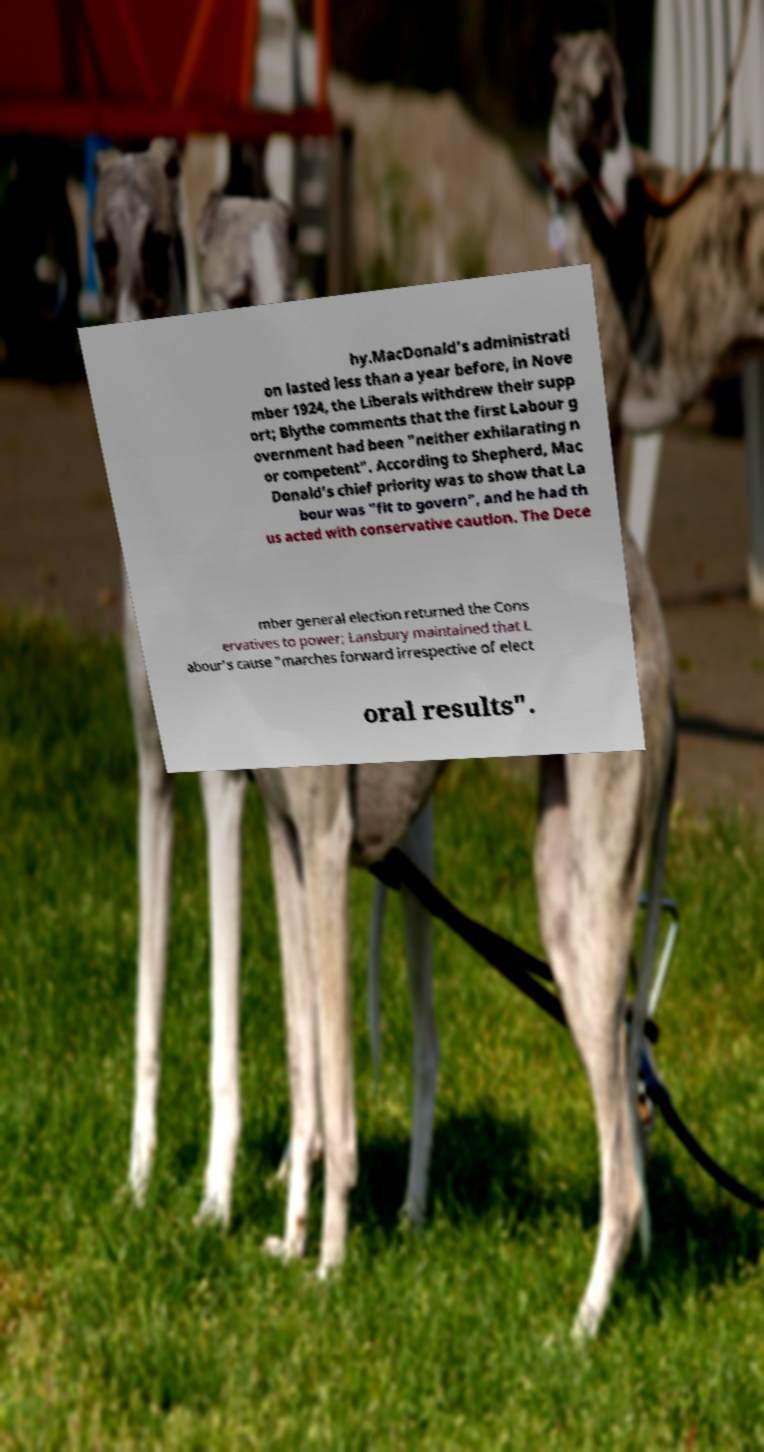Could you extract and type out the text from this image? hy.MacDonald's administrati on lasted less than a year before, in Nove mber 1924, the Liberals withdrew their supp ort; Blythe comments that the first Labour g overnment had been "neither exhilarating n or competent". According to Shepherd, Mac Donald's chief priority was to show that La bour was "fit to govern", and he had th us acted with conservative caution. The Dece mber general election returned the Cons ervatives to power; Lansbury maintained that L abour's cause "marches forward irrespective of elect oral results". 